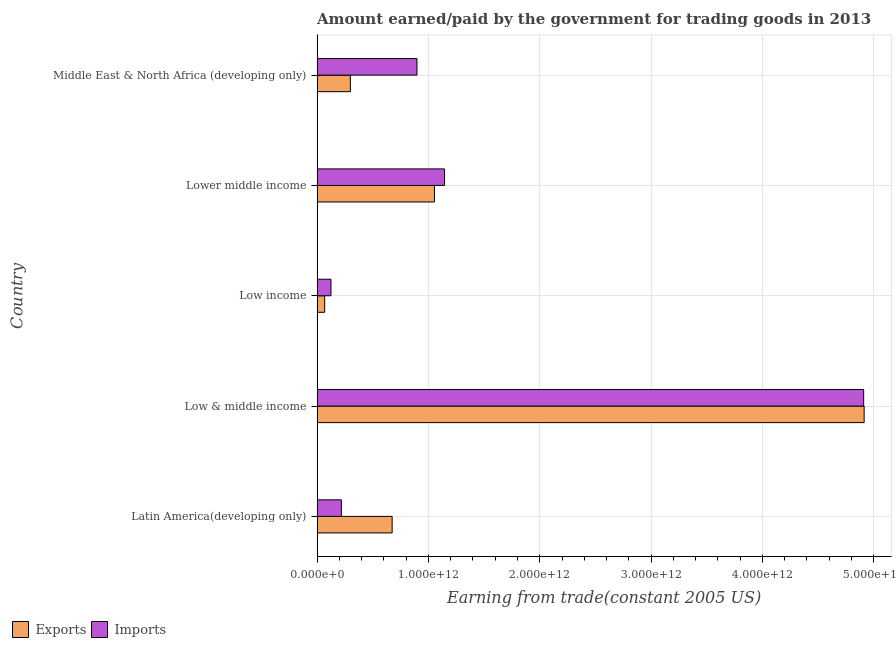How many groups of bars are there?
Your response must be concise. 5. Are the number of bars on each tick of the Y-axis equal?
Provide a succinct answer. Yes. How many bars are there on the 4th tick from the top?
Provide a short and direct response. 2. How many bars are there on the 3rd tick from the bottom?
Your response must be concise. 2. What is the label of the 3rd group of bars from the top?
Offer a terse response. Low income. What is the amount paid for imports in Lower middle income?
Make the answer very short. 1.14e+12. Across all countries, what is the maximum amount earned from exports?
Give a very brief answer. 4.91e+12. Across all countries, what is the minimum amount paid for imports?
Offer a terse response. 1.25e+11. In which country was the amount paid for imports maximum?
Make the answer very short. Low & middle income. What is the total amount paid for imports in the graph?
Your answer should be very brief. 7.29e+12. What is the difference between the amount paid for imports in Low income and that in Lower middle income?
Ensure brevity in your answer.  -1.02e+12. What is the difference between the amount paid for imports in Latin America(developing only) and the amount earned from exports in Lower middle income?
Provide a succinct answer. -8.36e+11. What is the average amount paid for imports per country?
Provide a short and direct response. 1.46e+12. What is the difference between the amount earned from exports and amount paid for imports in Low & middle income?
Give a very brief answer. 4.38e+09. In how many countries, is the amount paid for imports greater than 2000000000000 US$?
Your response must be concise. 1. What is the ratio of the amount paid for imports in Low income to that in Lower middle income?
Offer a very short reply. 0.11. Is the amount earned from exports in Low & middle income less than that in Low income?
Ensure brevity in your answer.  No. Is the difference between the amount paid for imports in Latin America(developing only) and Low income greater than the difference between the amount earned from exports in Latin America(developing only) and Low income?
Keep it short and to the point. No. What is the difference between the highest and the second highest amount earned from exports?
Offer a terse response. 3.86e+12. What is the difference between the highest and the lowest amount paid for imports?
Keep it short and to the point. 4.78e+12. In how many countries, is the amount earned from exports greater than the average amount earned from exports taken over all countries?
Keep it short and to the point. 1. Is the sum of the amount earned from exports in Latin America(developing only) and Middle East & North Africa (developing only) greater than the maximum amount paid for imports across all countries?
Keep it short and to the point. No. What does the 1st bar from the top in Lower middle income represents?
Your answer should be very brief. Imports. What does the 1st bar from the bottom in Lower middle income represents?
Ensure brevity in your answer.  Exports. How many countries are there in the graph?
Keep it short and to the point. 5. What is the difference between two consecutive major ticks on the X-axis?
Provide a succinct answer. 1.00e+12. Are the values on the major ticks of X-axis written in scientific E-notation?
Ensure brevity in your answer.  Yes. Does the graph contain any zero values?
Give a very brief answer. No. Where does the legend appear in the graph?
Your response must be concise. Bottom left. How are the legend labels stacked?
Make the answer very short. Horizontal. What is the title of the graph?
Your response must be concise. Amount earned/paid by the government for trading goods in 2013. Does "Stunting" appear as one of the legend labels in the graph?
Offer a very short reply. No. What is the label or title of the X-axis?
Ensure brevity in your answer.  Earning from trade(constant 2005 US). What is the label or title of the Y-axis?
Your answer should be very brief. Country. What is the Earning from trade(constant 2005 US) in Exports in Latin America(developing only)?
Provide a short and direct response. 6.74e+11. What is the Earning from trade(constant 2005 US) of Imports in Latin America(developing only)?
Offer a very short reply. 2.18e+11. What is the Earning from trade(constant 2005 US) of Exports in Low & middle income?
Ensure brevity in your answer.  4.91e+12. What is the Earning from trade(constant 2005 US) of Imports in Low & middle income?
Offer a very short reply. 4.91e+12. What is the Earning from trade(constant 2005 US) in Exports in Low income?
Give a very brief answer. 6.86e+1. What is the Earning from trade(constant 2005 US) of Imports in Low income?
Offer a very short reply. 1.25e+11. What is the Earning from trade(constant 2005 US) of Exports in Lower middle income?
Provide a succinct answer. 1.05e+12. What is the Earning from trade(constant 2005 US) in Imports in Lower middle income?
Your answer should be very brief. 1.14e+12. What is the Earning from trade(constant 2005 US) of Exports in Middle East & North Africa (developing only)?
Your answer should be compact. 2.99e+11. What is the Earning from trade(constant 2005 US) of Imports in Middle East & North Africa (developing only)?
Your answer should be compact. 8.97e+11. Across all countries, what is the maximum Earning from trade(constant 2005 US) in Exports?
Give a very brief answer. 4.91e+12. Across all countries, what is the maximum Earning from trade(constant 2005 US) in Imports?
Keep it short and to the point. 4.91e+12. Across all countries, what is the minimum Earning from trade(constant 2005 US) in Exports?
Ensure brevity in your answer.  6.86e+1. Across all countries, what is the minimum Earning from trade(constant 2005 US) of Imports?
Make the answer very short. 1.25e+11. What is the total Earning from trade(constant 2005 US) of Exports in the graph?
Keep it short and to the point. 7.01e+12. What is the total Earning from trade(constant 2005 US) in Imports in the graph?
Your answer should be very brief. 7.29e+12. What is the difference between the Earning from trade(constant 2005 US) of Exports in Latin America(developing only) and that in Low & middle income?
Give a very brief answer. -4.24e+12. What is the difference between the Earning from trade(constant 2005 US) of Imports in Latin America(developing only) and that in Low & middle income?
Make the answer very short. -4.69e+12. What is the difference between the Earning from trade(constant 2005 US) of Exports in Latin America(developing only) and that in Low income?
Offer a terse response. 6.06e+11. What is the difference between the Earning from trade(constant 2005 US) of Imports in Latin America(developing only) and that in Low income?
Provide a short and direct response. 9.33e+1. What is the difference between the Earning from trade(constant 2005 US) in Exports in Latin America(developing only) and that in Lower middle income?
Keep it short and to the point. -3.80e+11. What is the difference between the Earning from trade(constant 2005 US) in Imports in Latin America(developing only) and that in Lower middle income?
Your answer should be very brief. -9.26e+11. What is the difference between the Earning from trade(constant 2005 US) in Exports in Latin America(developing only) and that in Middle East & North Africa (developing only)?
Make the answer very short. 3.75e+11. What is the difference between the Earning from trade(constant 2005 US) in Imports in Latin America(developing only) and that in Middle East & North Africa (developing only)?
Your response must be concise. -6.79e+11. What is the difference between the Earning from trade(constant 2005 US) in Exports in Low & middle income and that in Low income?
Provide a short and direct response. 4.84e+12. What is the difference between the Earning from trade(constant 2005 US) in Imports in Low & middle income and that in Low income?
Your answer should be compact. 4.78e+12. What is the difference between the Earning from trade(constant 2005 US) in Exports in Low & middle income and that in Lower middle income?
Make the answer very short. 3.86e+12. What is the difference between the Earning from trade(constant 2005 US) in Imports in Low & middle income and that in Lower middle income?
Give a very brief answer. 3.76e+12. What is the difference between the Earning from trade(constant 2005 US) in Exports in Low & middle income and that in Middle East & North Africa (developing only)?
Offer a very short reply. 4.61e+12. What is the difference between the Earning from trade(constant 2005 US) of Imports in Low & middle income and that in Middle East & North Africa (developing only)?
Make the answer very short. 4.01e+12. What is the difference between the Earning from trade(constant 2005 US) of Exports in Low income and that in Lower middle income?
Make the answer very short. -9.86e+11. What is the difference between the Earning from trade(constant 2005 US) in Imports in Low income and that in Lower middle income?
Your answer should be compact. -1.02e+12. What is the difference between the Earning from trade(constant 2005 US) of Exports in Low income and that in Middle East & North Africa (developing only)?
Give a very brief answer. -2.31e+11. What is the difference between the Earning from trade(constant 2005 US) in Imports in Low income and that in Middle East & North Africa (developing only)?
Keep it short and to the point. -7.72e+11. What is the difference between the Earning from trade(constant 2005 US) in Exports in Lower middle income and that in Middle East & North Africa (developing only)?
Ensure brevity in your answer.  7.56e+11. What is the difference between the Earning from trade(constant 2005 US) of Imports in Lower middle income and that in Middle East & North Africa (developing only)?
Your response must be concise. 2.47e+11. What is the difference between the Earning from trade(constant 2005 US) of Exports in Latin America(developing only) and the Earning from trade(constant 2005 US) of Imports in Low & middle income?
Your answer should be compact. -4.23e+12. What is the difference between the Earning from trade(constant 2005 US) of Exports in Latin America(developing only) and the Earning from trade(constant 2005 US) of Imports in Low income?
Ensure brevity in your answer.  5.49e+11. What is the difference between the Earning from trade(constant 2005 US) of Exports in Latin America(developing only) and the Earning from trade(constant 2005 US) of Imports in Lower middle income?
Provide a short and direct response. -4.70e+11. What is the difference between the Earning from trade(constant 2005 US) of Exports in Latin America(developing only) and the Earning from trade(constant 2005 US) of Imports in Middle East & North Africa (developing only)?
Offer a terse response. -2.23e+11. What is the difference between the Earning from trade(constant 2005 US) in Exports in Low & middle income and the Earning from trade(constant 2005 US) in Imports in Low income?
Provide a short and direct response. 4.79e+12. What is the difference between the Earning from trade(constant 2005 US) in Exports in Low & middle income and the Earning from trade(constant 2005 US) in Imports in Lower middle income?
Your answer should be compact. 3.77e+12. What is the difference between the Earning from trade(constant 2005 US) of Exports in Low & middle income and the Earning from trade(constant 2005 US) of Imports in Middle East & North Africa (developing only)?
Offer a terse response. 4.02e+12. What is the difference between the Earning from trade(constant 2005 US) in Exports in Low income and the Earning from trade(constant 2005 US) in Imports in Lower middle income?
Offer a terse response. -1.08e+12. What is the difference between the Earning from trade(constant 2005 US) of Exports in Low income and the Earning from trade(constant 2005 US) of Imports in Middle East & North Africa (developing only)?
Your response must be concise. -8.29e+11. What is the difference between the Earning from trade(constant 2005 US) of Exports in Lower middle income and the Earning from trade(constant 2005 US) of Imports in Middle East & North Africa (developing only)?
Provide a short and direct response. 1.57e+11. What is the average Earning from trade(constant 2005 US) of Exports per country?
Your response must be concise. 1.40e+12. What is the average Earning from trade(constant 2005 US) in Imports per country?
Provide a succinct answer. 1.46e+12. What is the difference between the Earning from trade(constant 2005 US) of Exports and Earning from trade(constant 2005 US) of Imports in Latin America(developing only)?
Offer a very short reply. 4.56e+11. What is the difference between the Earning from trade(constant 2005 US) of Exports and Earning from trade(constant 2005 US) of Imports in Low & middle income?
Provide a succinct answer. 4.38e+09. What is the difference between the Earning from trade(constant 2005 US) of Exports and Earning from trade(constant 2005 US) of Imports in Low income?
Give a very brief answer. -5.64e+1. What is the difference between the Earning from trade(constant 2005 US) in Exports and Earning from trade(constant 2005 US) in Imports in Lower middle income?
Your answer should be compact. -8.99e+1. What is the difference between the Earning from trade(constant 2005 US) of Exports and Earning from trade(constant 2005 US) of Imports in Middle East & North Africa (developing only)?
Give a very brief answer. -5.98e+11. What is the ratio of the Earning from trade(constant 2005 US) in Exports in Latin America(developing only) to that in Low & middle income?
Keep it short and to the point. 0.14. What is the ratio of the Earning from trade(constant 2005 US) in Imports in Latin America(developing only) to that in Low & middle income?
Your answer should be very brief. 0.04. What is the ratio of the Earning from trade(constant 2005 US) of Exports in Latin America(developing only) to that in Low income?
Your answer should be compact. 9.84. What is the ratio of the Earning from trade(constant 2005 US) in Imports in Latin America(developing only) to that in Low income?
Offer a terse response. 1.75. What is the ratio of the Earning from trade(constant 2005 US) in Exports in Latin America(developing only) to that in Lower middle income?
Your answer should be compact. 0.64. What is the ratio of the Earning from trade(constant 2005 US) of Imports in Latin America(developing only) to that in Lower middle income?
Keep it short and to the point. 0.19. What is the ratio of the Earning from trade(constant 2005 US) of Exports in Latin America(developing only) to that in Middle East & North Africa (developing only)?
Provide a short and direct response. 2.25. What is the ratio of the Earning from trade(constant 2005 US) in Imports in Latin America(developing only) to that in Middle East & North Africa (developing only)?
Your answer should be compact. 0.24. What is the ratio of the Earning from trade(constant 2005 US) of Exports in Low & middle income to that in Low income?
Your answer should be very brief. 71.67. What is the ratio of the Earning from trade(constant 2005 US) in Imports in Low & middle income to that in Low income?
Provide a short and direct response. 39.28. What is the ratio of the Earning from trade(constant 2005 US) in Exports in Low & middle income to that in Lower middle income?
Keep it short and to the point. 4.66. What is the ratio of the Earning from trade(constant 2005 US) in Imports in Low & middle income to that in Lower middle income?
Make the answer very short. 4.29. What is the ratio of the Earning from trade(constant 2005 US) in Exports in Low & middle income to that in Middle East & North Africa (developing only)?
Your answer should be compact. 16.43. What is the ratio of the Earning from trade(constant 2005 US) of Imports in Low & middle income to that in Middle East & North Africa (developing only)?
Give a very brief answer. 5.47. What is the ratio of the Earning from trade(constant 2005 US) in Exports in Low income to that in Lower middle income?
Your answer should be very brief. 0.07. What is the ratio of the Earning from trade(constant 2005 US) of Imports in Low income to that in Lower middle income?
Offer a very short reply. 0.11. What is the ratio of the Earning from trade(constant 2005 US) of Exports in Low income to that in Middle East & North Africa (developing only)?
Your response must be concise. 0.23. What is the ratio of the Earning from trade(constant 2005 US) in Imports in Low income to that in Middle East & North Africa (developing only)?
Ensure brevity in your answer.  0.14. What is the ratio of the Earning from trade(constant 2005 US) of Exports in Lower middle income to that in Middle East & North Africa (developing only)?
Provide a succinct answer. 3.53. What is the ratio of the Earning from trade(constant 2005 US) in Imports in Lower middle income to that in Middle East & North Africa (developing only)?
Offer a very short reply. 1.28. What is the difference between the highest and the second highest Earning from trade(constant 2005 US) in Exports?
Offer a terse response. 3.86e+12. What is the difference between the highest and the second highest Earning from trade(constant 2005 US) of Imports?
Make the answer very short. 3.76e+12. What is the difference between the highest and the lowest Earning from trade(constant 2005 US) of Exports?
Your response must be concise. 4.84e+12. What is the difference between the highest and the lowest Earning from trade(constant 2005 US) of Imports?
Offer a very short reply. 4.78e+12. 